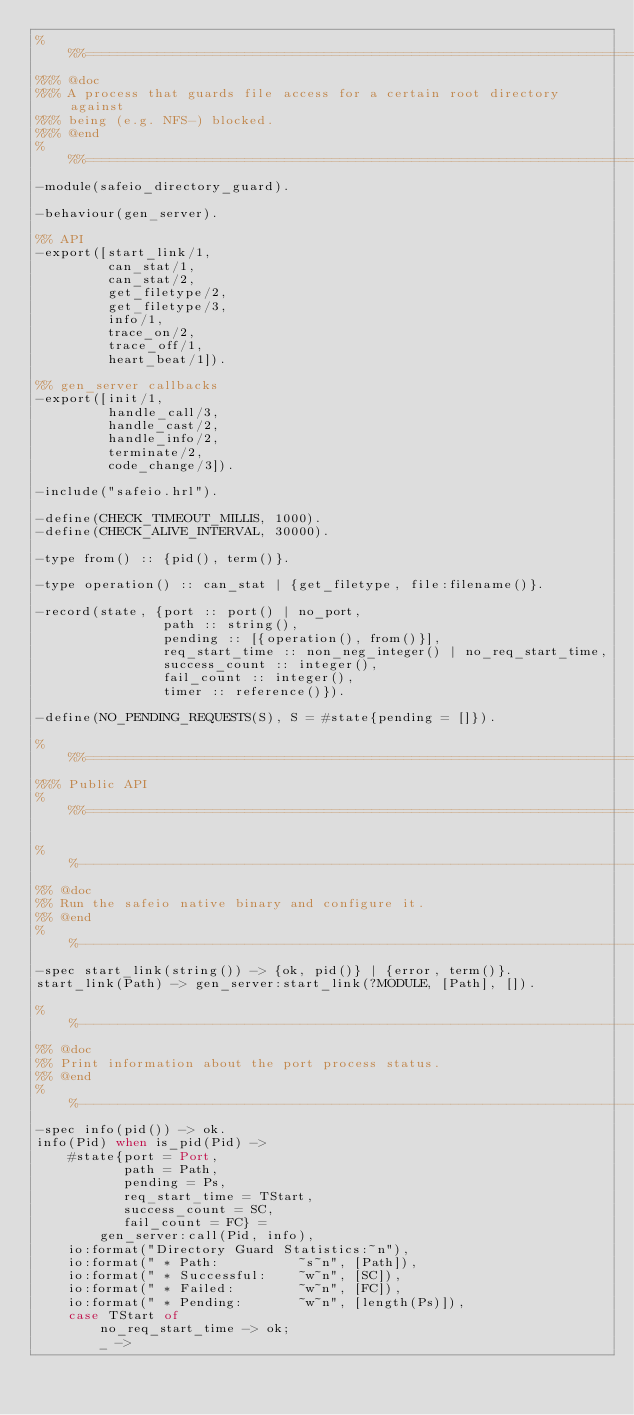Convert code to text. <code><loc_0><loc_0><loc_500><loc_500><_Erlang_>%%%=============================================================================
%%% @doc
%%% A process that guards file access for a certain root directory against
%%% being (e.g. NFS-) blocked.
%%% @end
%%%=============================================================================
-module(safeio_directory_guard).

-behaviour(gen_server).

%% API
-export([start_link/1,
         can_stat/1,
         can_stat/2,
         get_filetype/2,
         get_filetype/3,
         info/1,
         trace_on/2,
         trace_off/1,
         heart_beat/1]).

%% gen_server callbacks
-export([init/1,
         handle_call/3,
         handle_cast/2,
         handle_info/2,
         terminate/2,
         code_change/3]).

-include("safeio.hrl").

-define(CHECK_TIMEOUT_MILLIS, 1000).
-define(CHECK_ALIVE_INTERVAL, 30000).

-type from() :: {pid(), term()}.

-type operation() :: can_stat | {get_filetype, file:filename()}.

-record(state, {port :: port() | no_port,
                path :: string(),
                pending :: [{operation(), from()}],
                req_start_time :: non_neg_integer() | no_req_start_time,
                success_count :: integer(),
                fail_count :: integer(),
                timer :: reference()}).

-define(NO_PENDING_REQUESTS(S), S = #state{pending = []}).

%%%=============================================================================
%%% Public API
%%%=============================================================================

%%------------------------------------------------------------------------------
%% @doc
%% Run the safeio native binary and configure it.
%% @end
%%------------------------------------------------------------------------------
-spec start_link(string()) -> {ok, pid()} | {error, term()}.
start_link(Path) -> gen_server:start_link(?MODULE, [Path], []).

%%------------------------------------------------------------------------------
%% @doc
%% Print information about the port process status.
%% @end
%%------------------------------------------------------------------------------
-spec info(pid()) -> ok.
info(Pid) when is_pid(Pid) ->
    #state{port = Port,
           path = Path,
           pending = Ps,
           req_start_time = TStart,
           success_count = SC,
           fail_count = FC} =
        gen_server:call(Pid, info),
    io:format("Directory Guard Statistics:~n"),
    io:format(" * Path:          ~s~n", [Path]),
    io:format(" * Successful:    ~w~n", [SC]),
    io:format(" * Failed:        ~w~n", [FC]),
    io:format(" * Pending:       ~w~n", [length(Ps)]),
    case TStart of
        no_req_start_time -> ok;
        _ -></code> 